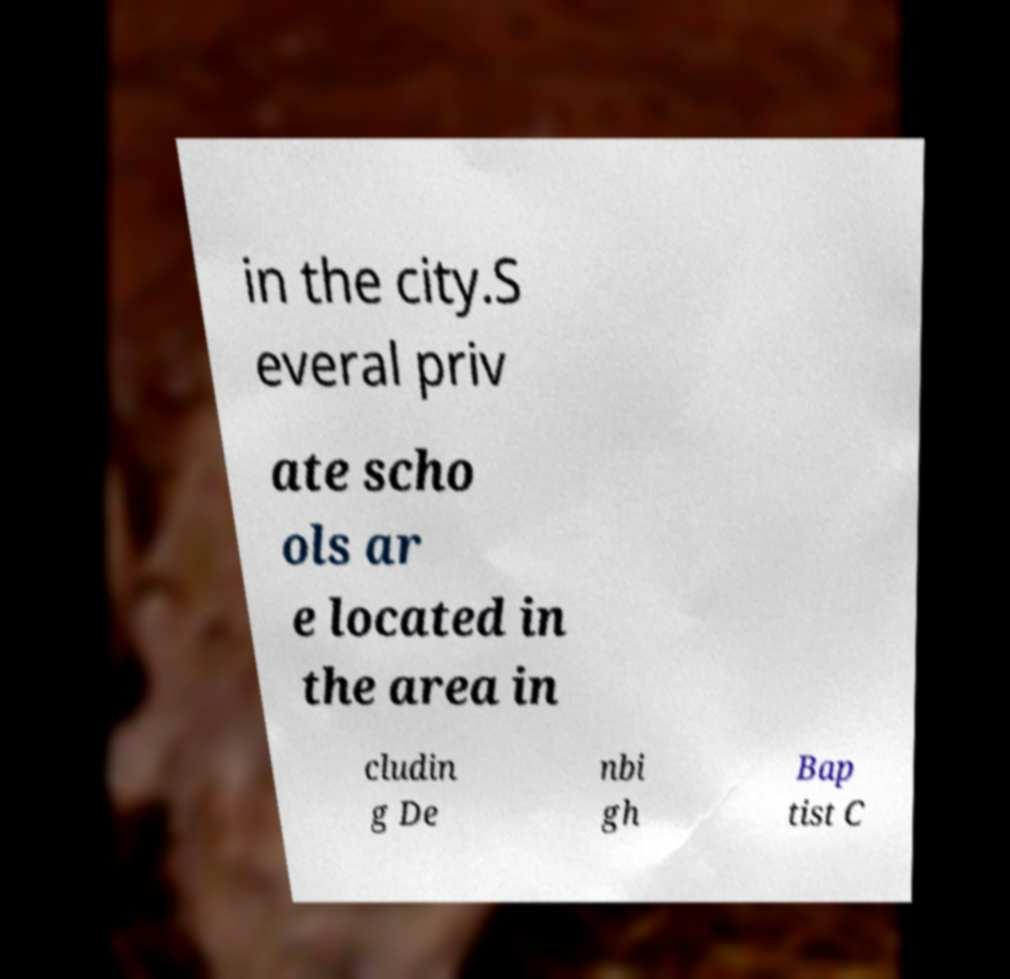I need the written content from this picture converted into text. Can you do that? in the city.S everal priv ate scho ols ar e located in the area in cludin g De nbi gh Bap tist C 